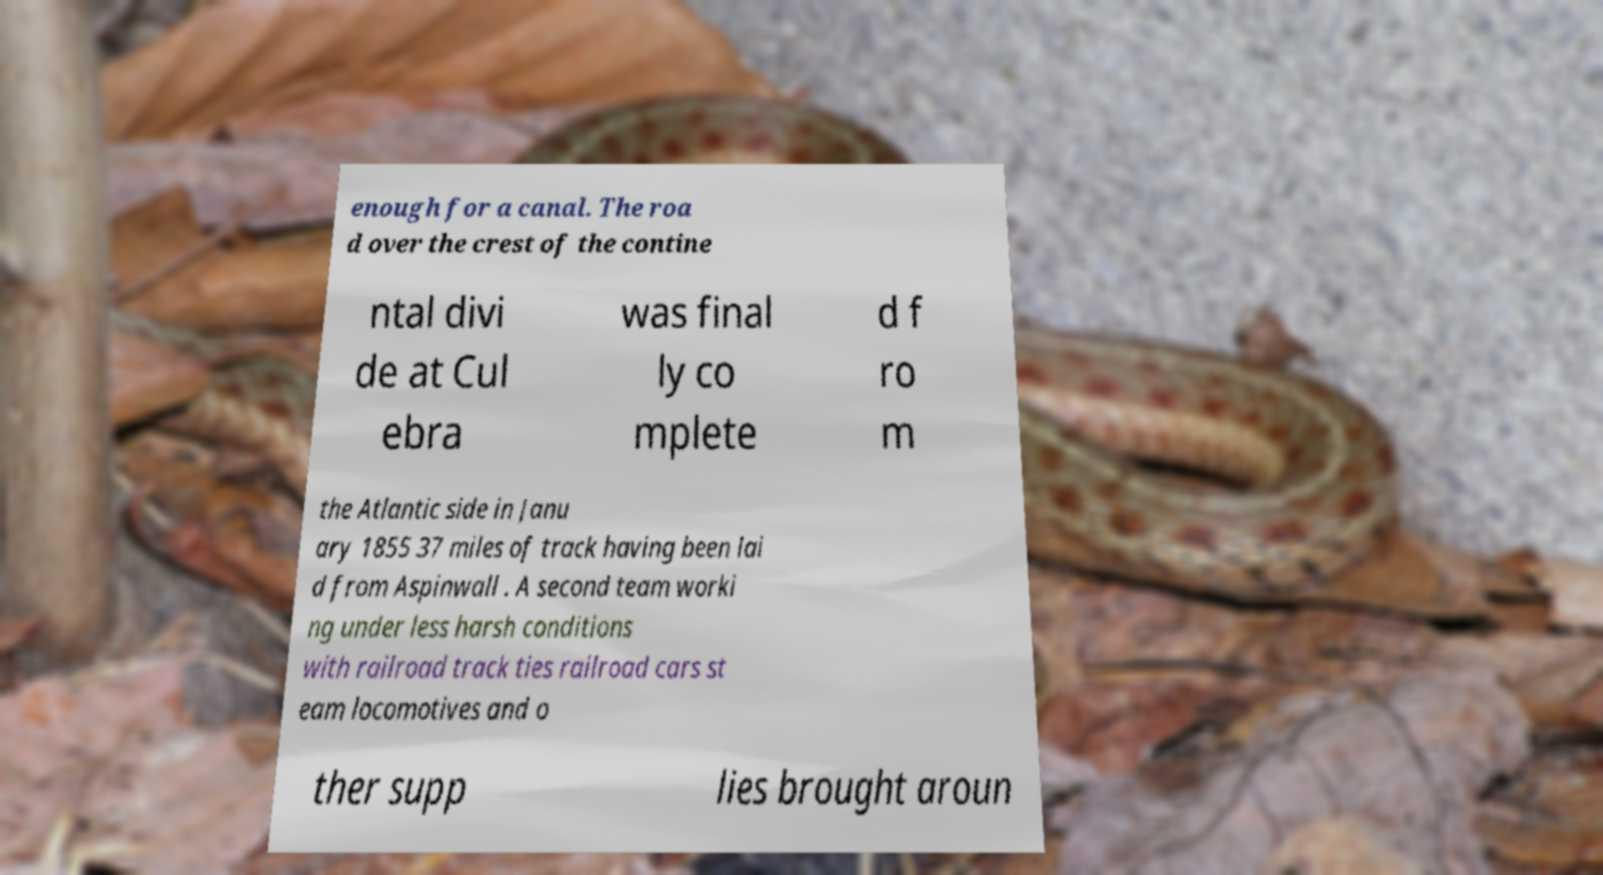There's text embedded in this image that I need extracted. Can you transcribe it verbatim? enough for a canal. The roa d over the crest of the contine ntal divi de at Cul ebra was final ly co mplete d f ro m the Atlantic side in Janu ary 1855 37 miles of track having been lai d from Aspinwall . A second team worki ng under less harsh conditions with railroad track ties railroad cars st eam locomotives and o ther supp lies brought aroun 